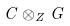Convert formula to latex. <formula><loc_0><loc_0><loc_500><loc_500>C \otimes _ { Z } G</formula> 